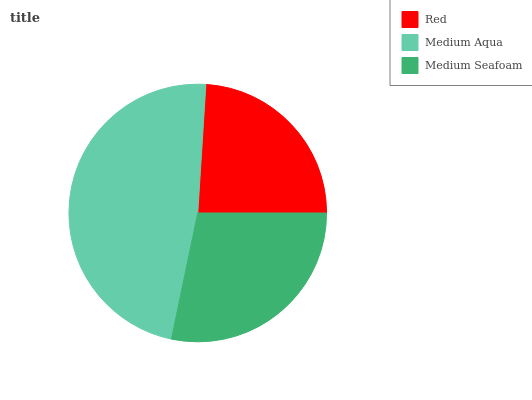Is Red the minimum?
Answer yes or no. Yes. Is Medium Aqua the maximum?
Answer yes or no. Yes. Is Medium Seafoam the minimum?
Answer yes or no. No. Is Medium Seafoam the maximum?
Answer yes or no. No. Is Medium Aqua greater than Medium Seafoam?
Answer yes or no. Yes. Is Medium Seafoam less than Medium Aqua?
Answer yes or no. Yes. Is Medium Seafoam greater than Medium Aqua?
Answer yes or no. No. Is Medium Aqua less than Medium Seafoam?
Answer yes or no. No. Is Medium Seafoam the high median?
Answer yes or no. Yes. Is Medium Seafoam the low median?
Answer yes or no. Yes. Is Medium Aqua the high median?
Answer yes or no. No. Is Red the low median?
Answer yes or no. No. 